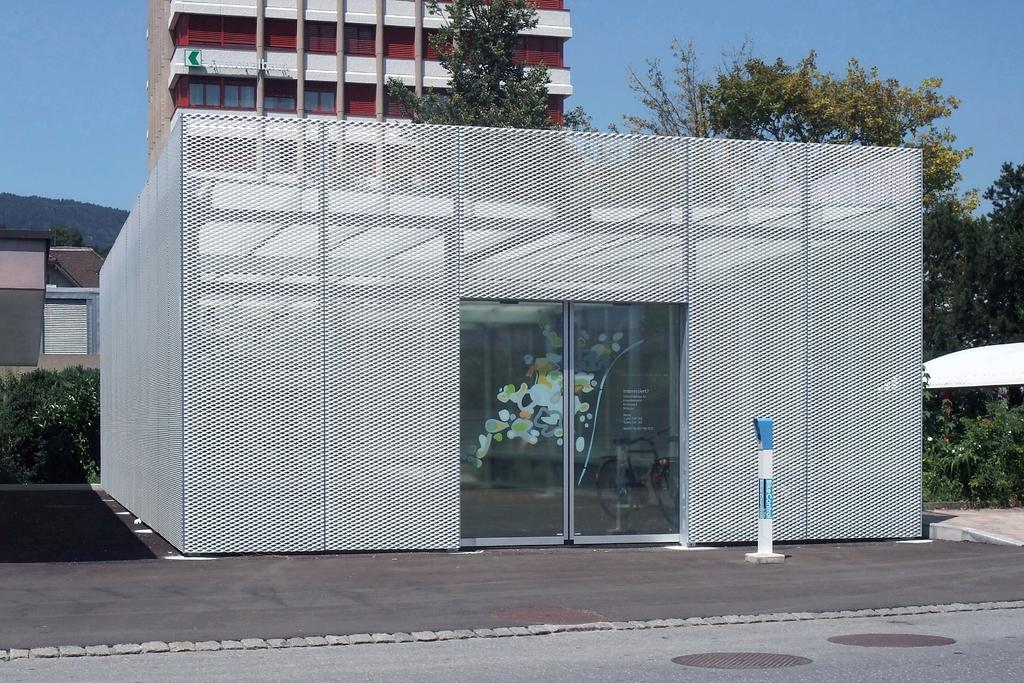What can be seen in the sky in the image? The sky is visible in the image. What type of structures are present in the image? There are buildings in the image. What other natural elements can be seen in the image? Trees are present in the image. Can you describe the transportation-related feature in the image? There is a bicycle inside a grill shed in the image. What type of pathway is visible in the image? A road is visible in the image. What type of farm animals can be seen grazing on the coil in the image? There is no farm or coil present in the image, and therefore no animals can be seen grazing on a coil. 